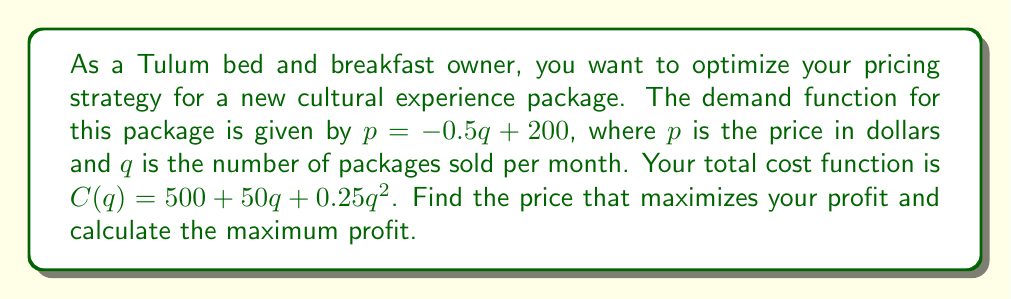Teach me how to tackle this problem. 1. First, we need to find the revenue function:
   $R(q) = pq = (-0.5q + 200)q = -0.5q^2 + 200q$

2. The profit function is revenue minus cost:
   $P(q) = R(q) - C(q)$
   $P(q) = (-0.5q^2 + 200q) - (500 + 50q + 0.25q^2)$
   $P(q) = -0.75q^2 + 150q - 500$

3. To find the maximum profit, we need to find the vertex of this quadratic function. We can do this by finding where the derivative equals zero:
   $P'(q) = -1.5q + 150$
   Set $P'(q) = 0$:
   $-1.5q + 150 = 0$
   $-1.5q = -150$
   $q = 100$

4. The optimal quantity is 100 packages per month. To find the optimal price, we substitute this into the demand function:
   $p = -0.5(100) + 200 = 150$

5. Calculate the maximum profit by substituting $q = 100$ into the profit function:
   $P(100) = -0.75(100)^2 + 150(100) - 500$
   $= -7500 + 15000 - 500 = 7000$
Answer: Optimal price: $150; Maximum profit: $7000 